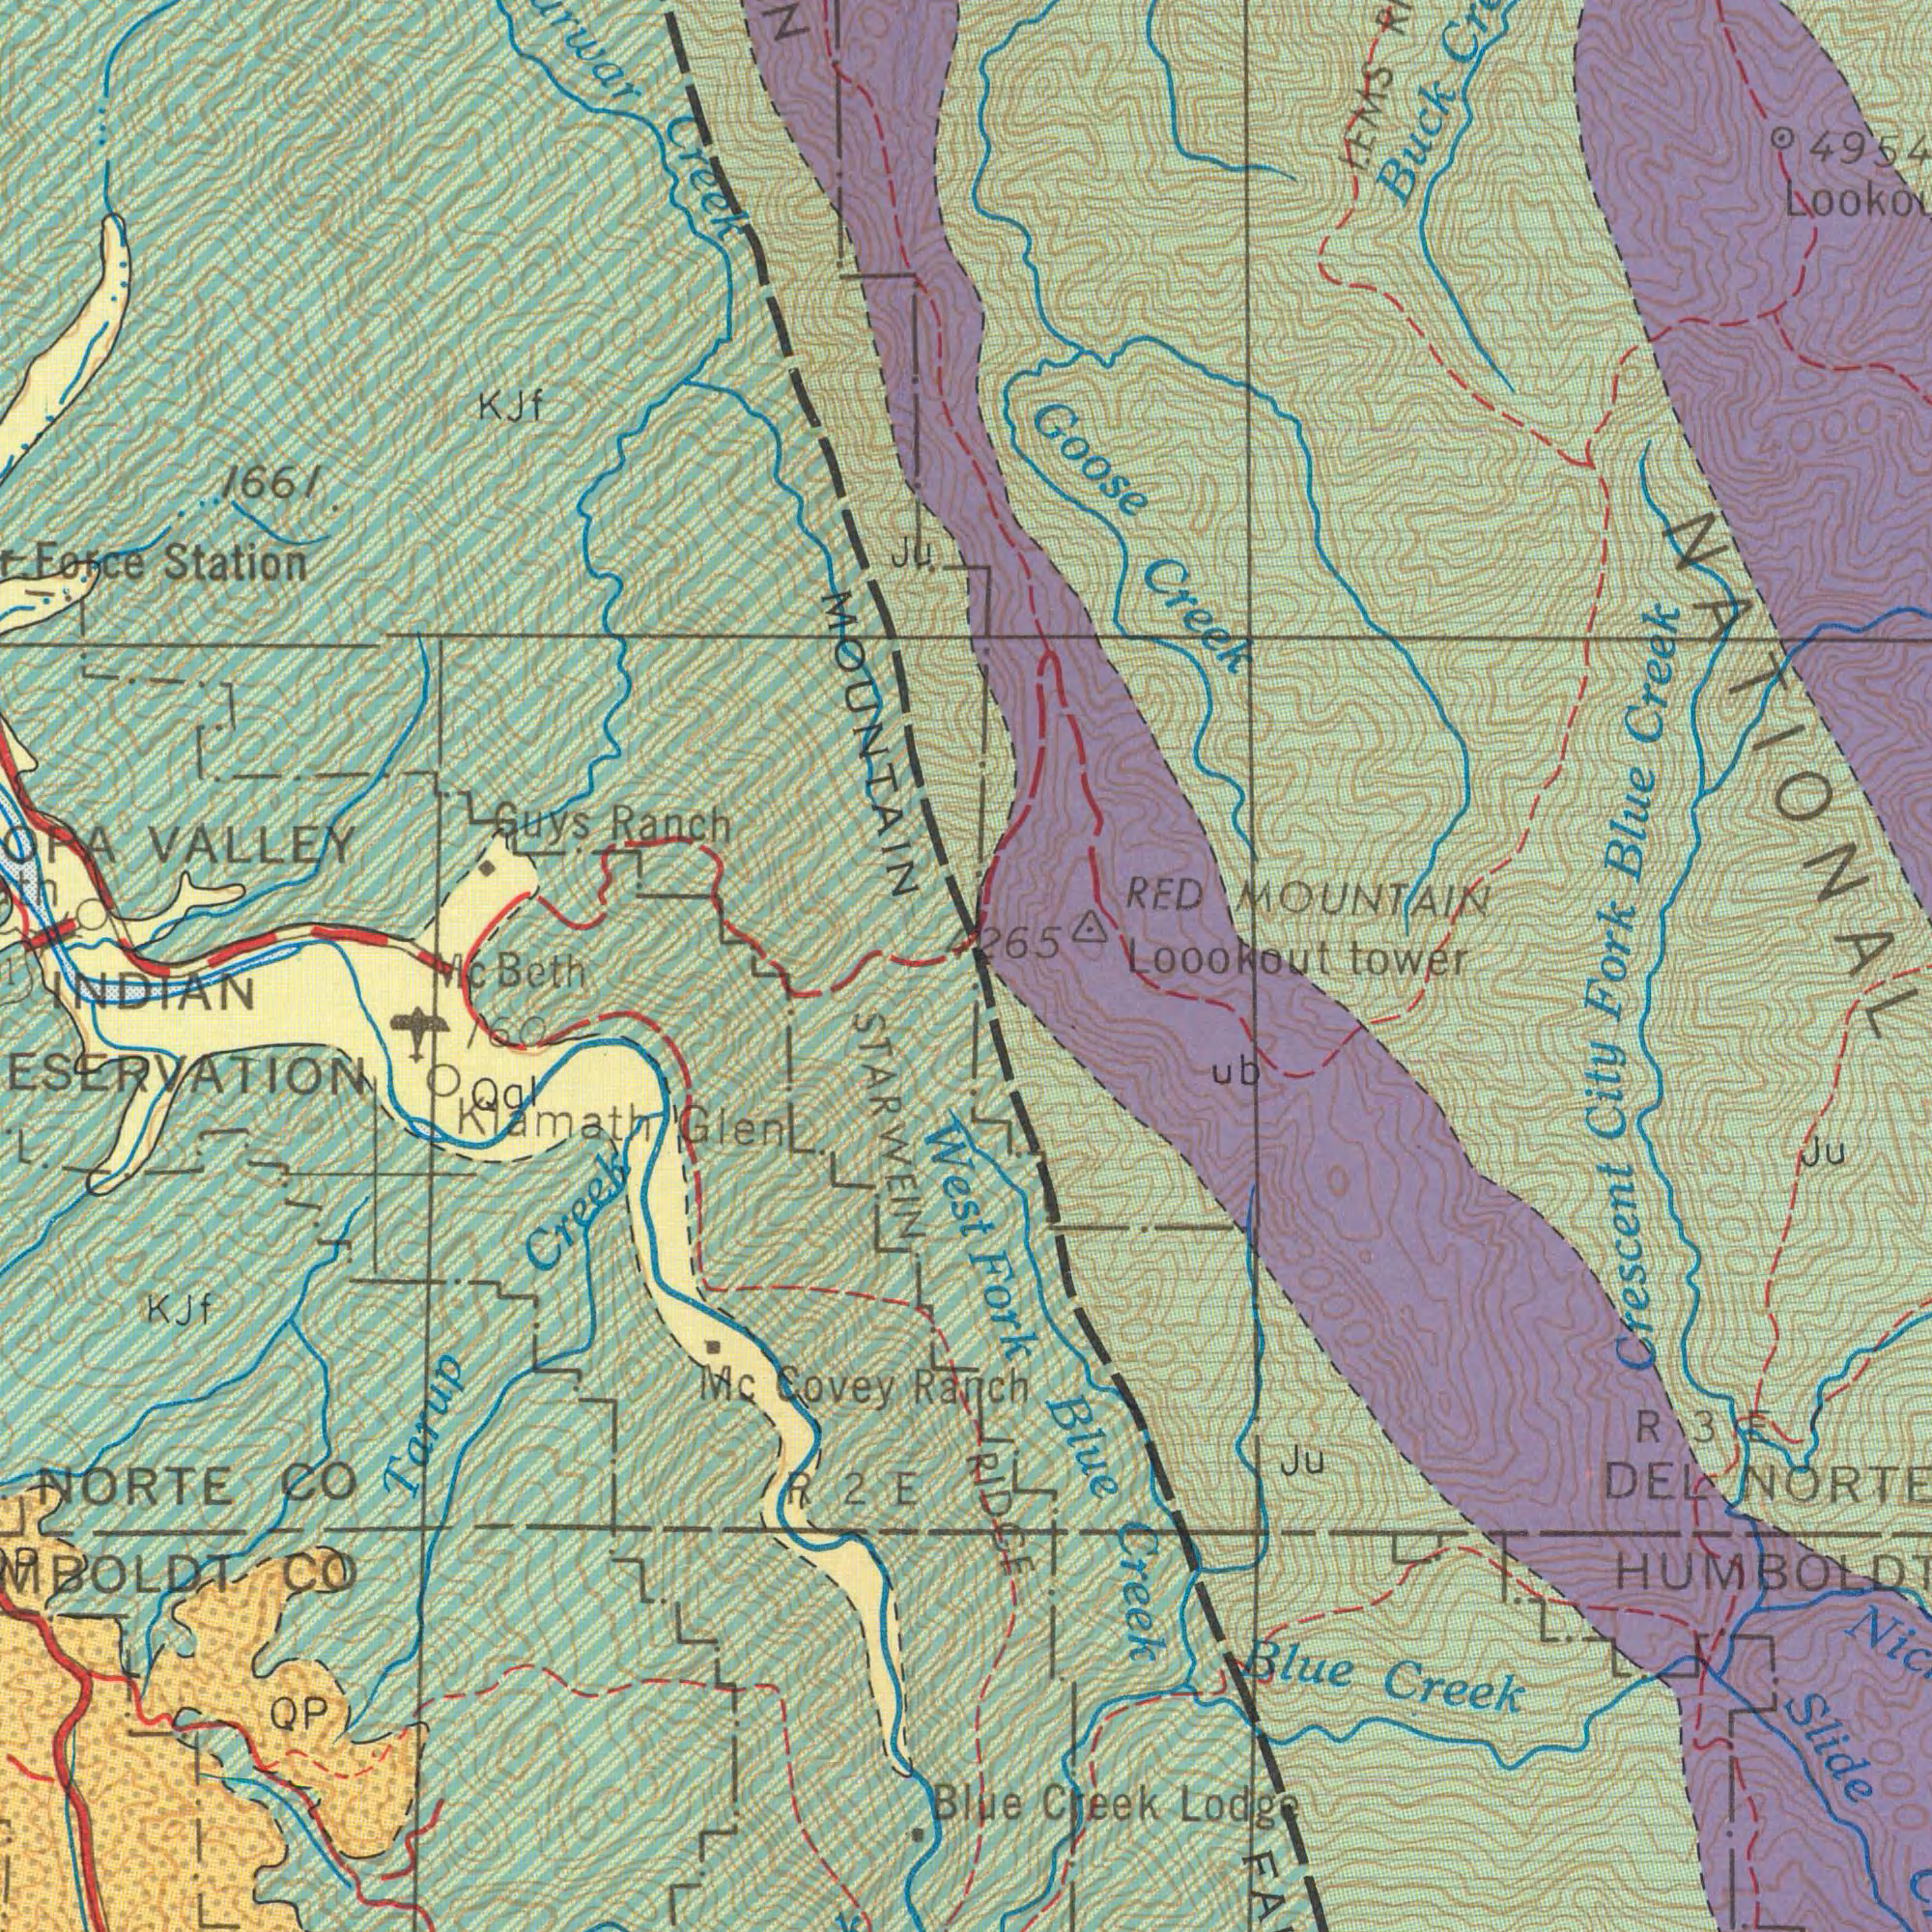What text appears in the top-right area of the image? Goose Creek Blue Creek Buck RED MOUNTAIN LEMS NATIONAL 4954 4000 What text can you see in the bottom-left section? Tarup Creek Mc Covey NORTE CO CO STARWEIN INDIAN QP Kjf Klamath Glen West Qal Beth 160 R 2 E 1000 What text is visible in the lower-right corner? Crescent City Fork 4265 Ranch RIDGE Blue Creek Lodge Fork Blue Creek Blue Creek DEL Slide Ju Ju R 3 ub Loookout tower 2000 3000 2000 2000 What text is visible in the upper-left corner? VALLEY Creek Force Station N Guys Ranch MOUNTAIN KJf ###tn 1661 Ju 2000 1000 1000 